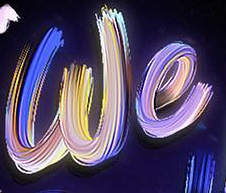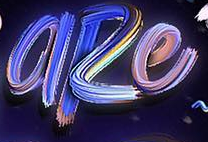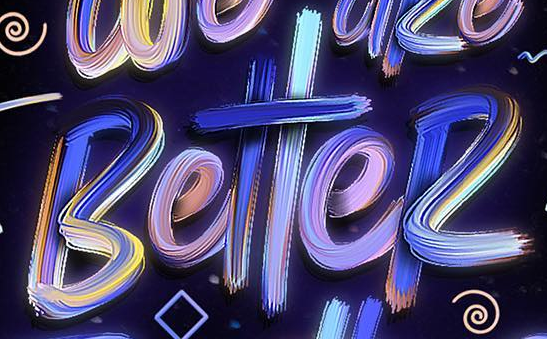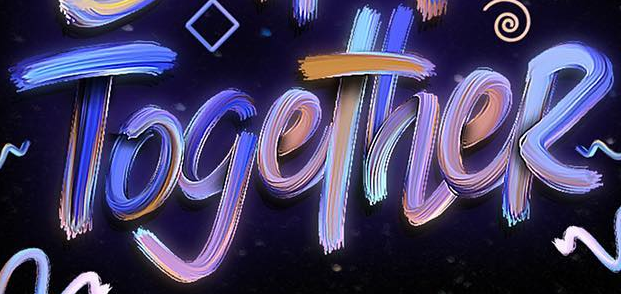Transcribe the words shown in these images in order, separated by a semicolon. we; aRe; BetteR; TogetheR 